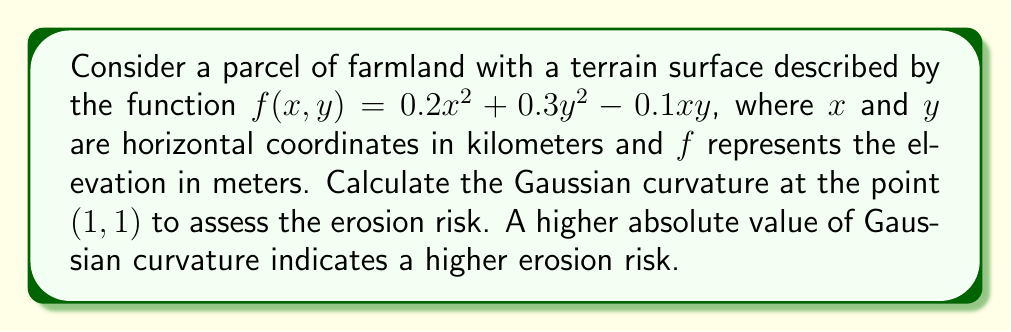Can you answer this question? To calculate the Gaussian curvature, we need to follow these steps:

1) The Gaussian curvature K is given by:
   $$K = \frac{f_{xx}f_{yy} - f_{xy}^2}{(1 + f_x^2 + f_y^2)^2}$$

2) Calculate the partial derivatives:
   $f_x = 0.4x - 0.1y$
   $f_y = 0.6y - 0.1x$
   $f_{xx} = 0.4$
   $f_{yy} = 0.6$
   $f_{xy} = -0.1$

3) Evaluate these at the point (1, 1):
   $f_x(1,1) = 0.4 - 0.1 = 0.3$
   $f_y(1,1) = 0.6 - 0.1 = 0.5$
   $f_{xx}(1,1) = 0.4$
   $f_{yy}(1,1) = 0.6$
   $f_{xy}(1,1) = -0.1$

4) Calculate the numerator:
   $f_{xx}f_{yy} - f_{xy}^2 = 0.4 * 0.6 - (-0.1)^2 = 0.24 - 0.01 = 0.23$

5) Calculate the denominator:
   $(1 + f_x^2 + f_y^2)^2 = (1 + 0.3^2 + 0.5^2)^2 = (1.34)^2 = 1.7956$

6) Finally, calculate K:
   $$K = \frac{0.23}{1.7956} = 0.1281$$

The Gaussian curvature at (1, 1) is approximately 0.1281 km^(-2).
Answer: 0.1281 km^(-2) 